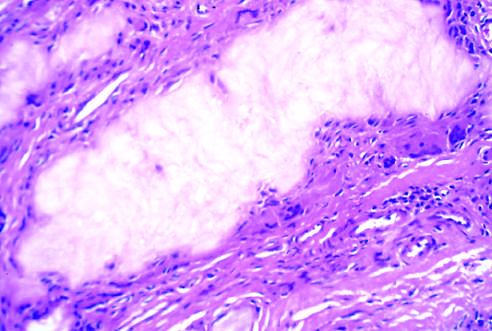what is an aggregate of dissolved urate crystals cells surrounded by?
Answer the question using a single word or phrase. Reactive fibroblasts 